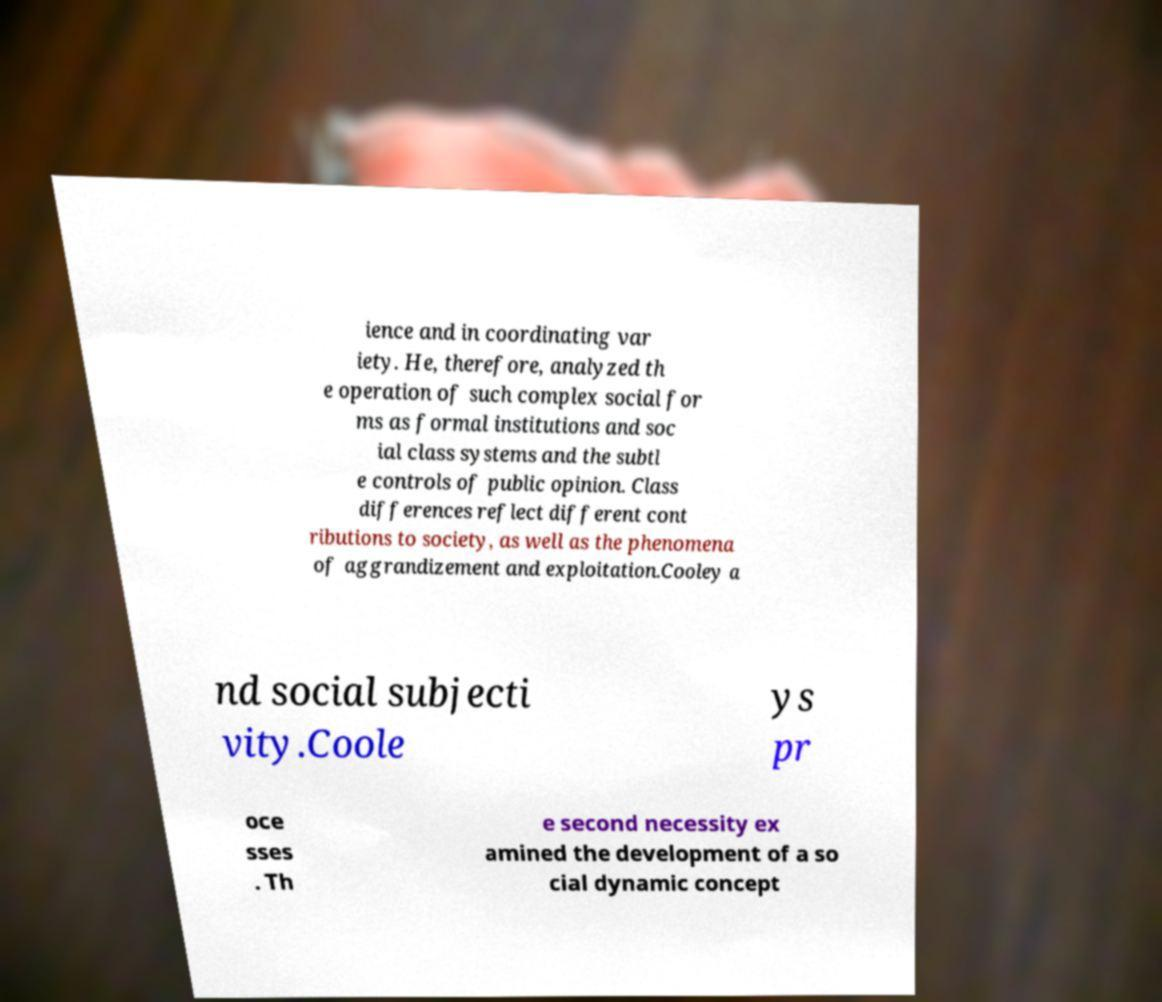Please read and relay the text visible in this image. What does it say? ience and in coordinating var iety. He, therefore, analyzed th e operation of such complex social for ms as formal institutions and soc ial class systems and the subtl e controls of public opinion. Class differences reflect different cont ributions to society, as well as the phenomena of aggrandizement and exploitation.Cooley a nd social subjecti vity.Coole ys pr oce sses . Th e second necessity ex amined the development of a so cial dynamic concept 